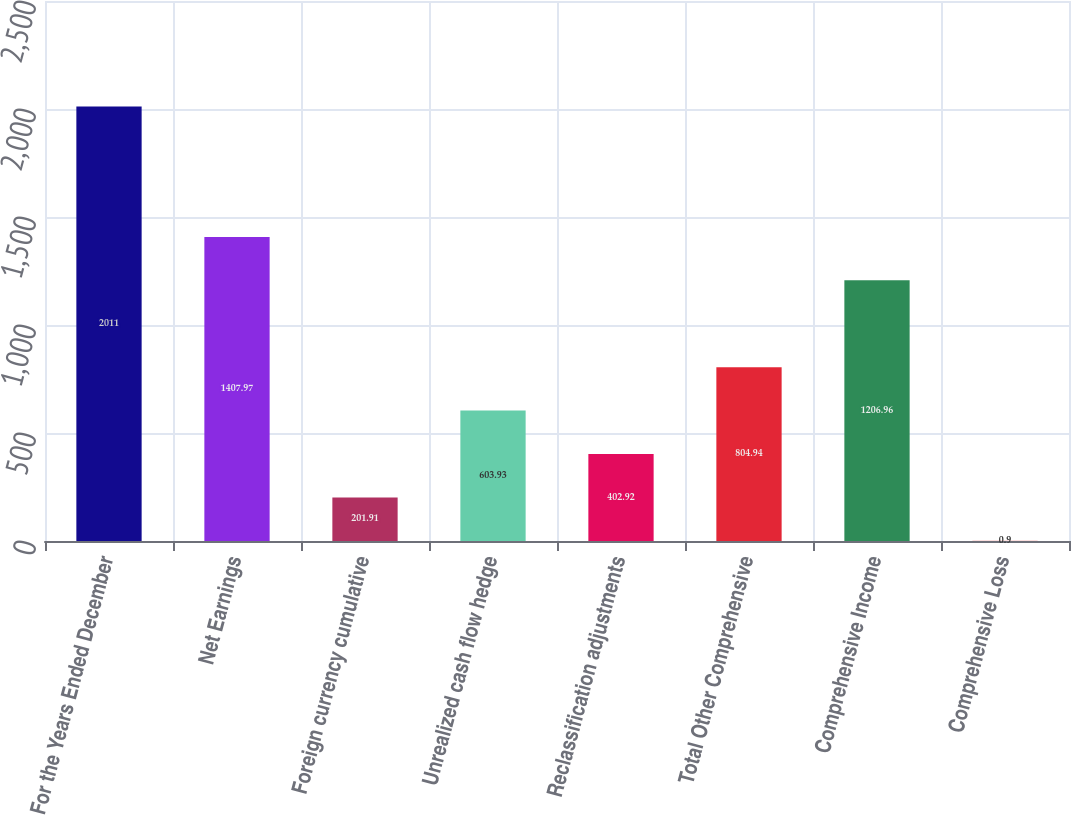Convert chart to OTSL. <chart><loc_0><loc_0><loc_500><loc_500><bar_chart><fcel>For the Years Ended December<fcel>Net Earnings<fcel>Foreign currency cumulative<fcel>Unrealized cash flow hedge<fcel>Reclassification adjustments<fcel>Total Other Comprehensive<fcel>Comprehensive Income<fcel>Comprehensive Loss<nl><fcel>2011<fcel>1407.97<fcel>201.91<fcel>603.93<fcel>402.92<fcel>804.94<fcel>1206.96<fcel>0.9<nl></chart> 